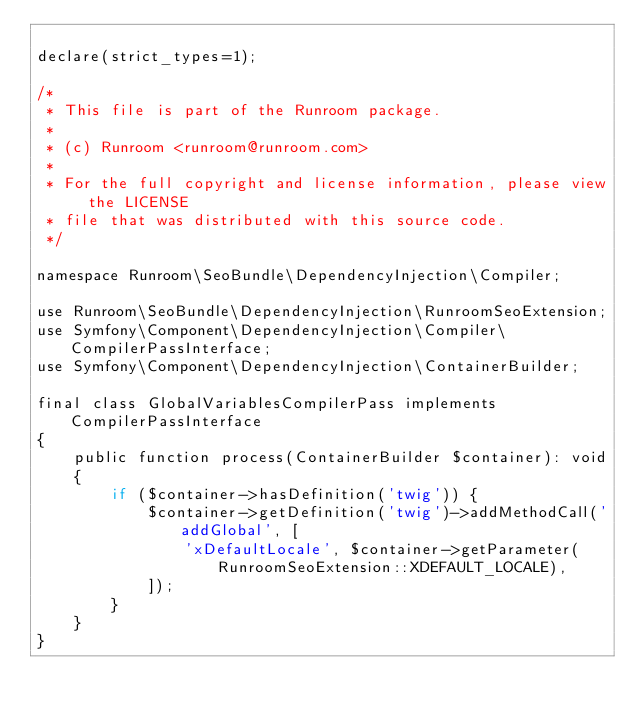<code> <loc_0><loc_0><loc_500><loc_500><_PHP_>
declare(strict_types=1);

/*
 * This file is part of the Runroom package.
 *
 * (c) Runroom <runroom@runroom.com>
 *
 * For the full copyright and license information, please view the LICENSE
 * file that was distributed with this source code.
 */

namespace Runroom\SeoBundle\DependencyInjection\Compiler;

use Runroom\SeoBundle\DependencyInjection\RunroomSeoExtension;
use Symfony\Component\DependencyInjection\Compiler\CompilerPassInterface;
use Symfony\Component\DependencyInjection\ContainerBuilder;

final class GlobalVariablesCompilerPass implements CompilerPassInterface
{
    public function process(ContainerBuilder $container): void
    {
        if ($container->hasDefinition('twig')) {
            $container->getDefinition('twig')->addMethodCall('addGlobal', [
                'xDefaultLocale', $container->getParameter(RunroomSeoExtension::XDEFAULT_LOCALE),
            ]);
        }
    }
}
</code> 